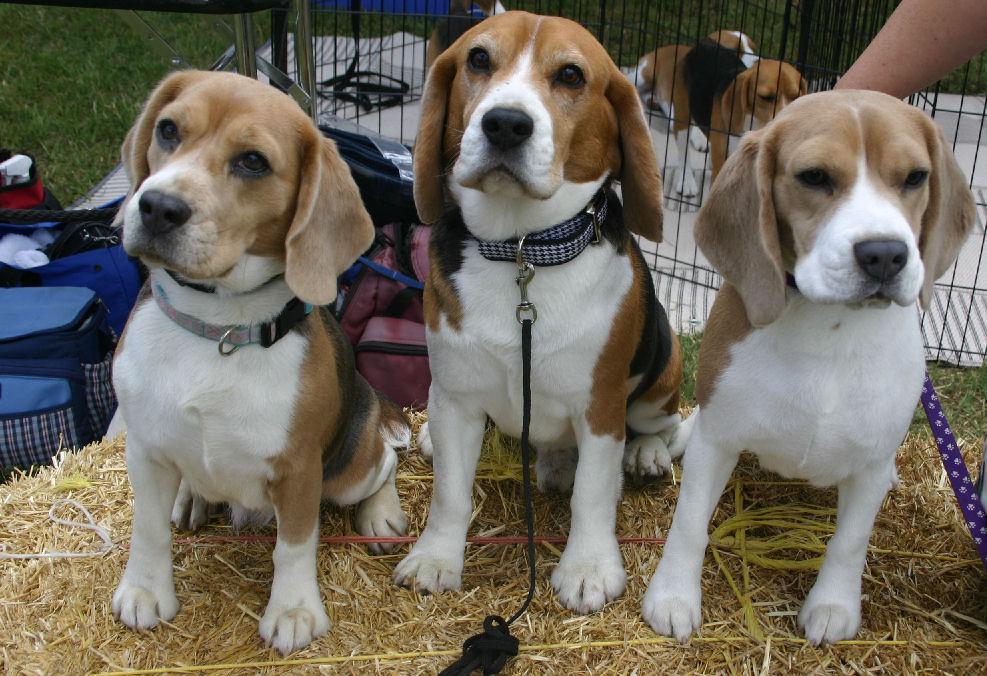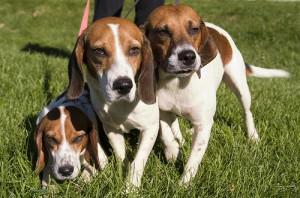The first image is the image on the left, the second image is the image on the right. Assess this claim about the two images: "One image shows three hounds posed on a rail, with the one in the middle taller than the others, and the other image shows three side-by-side dogs with the leftmost looking taller.". Correct or not? Answer yes or no. No. The first image is the image on the left, the second image is the image on the right. Given the left and right images, does the statement "There are three dogs in the grass in at least one of the images." hold true? Answer yes or no. Yes. 